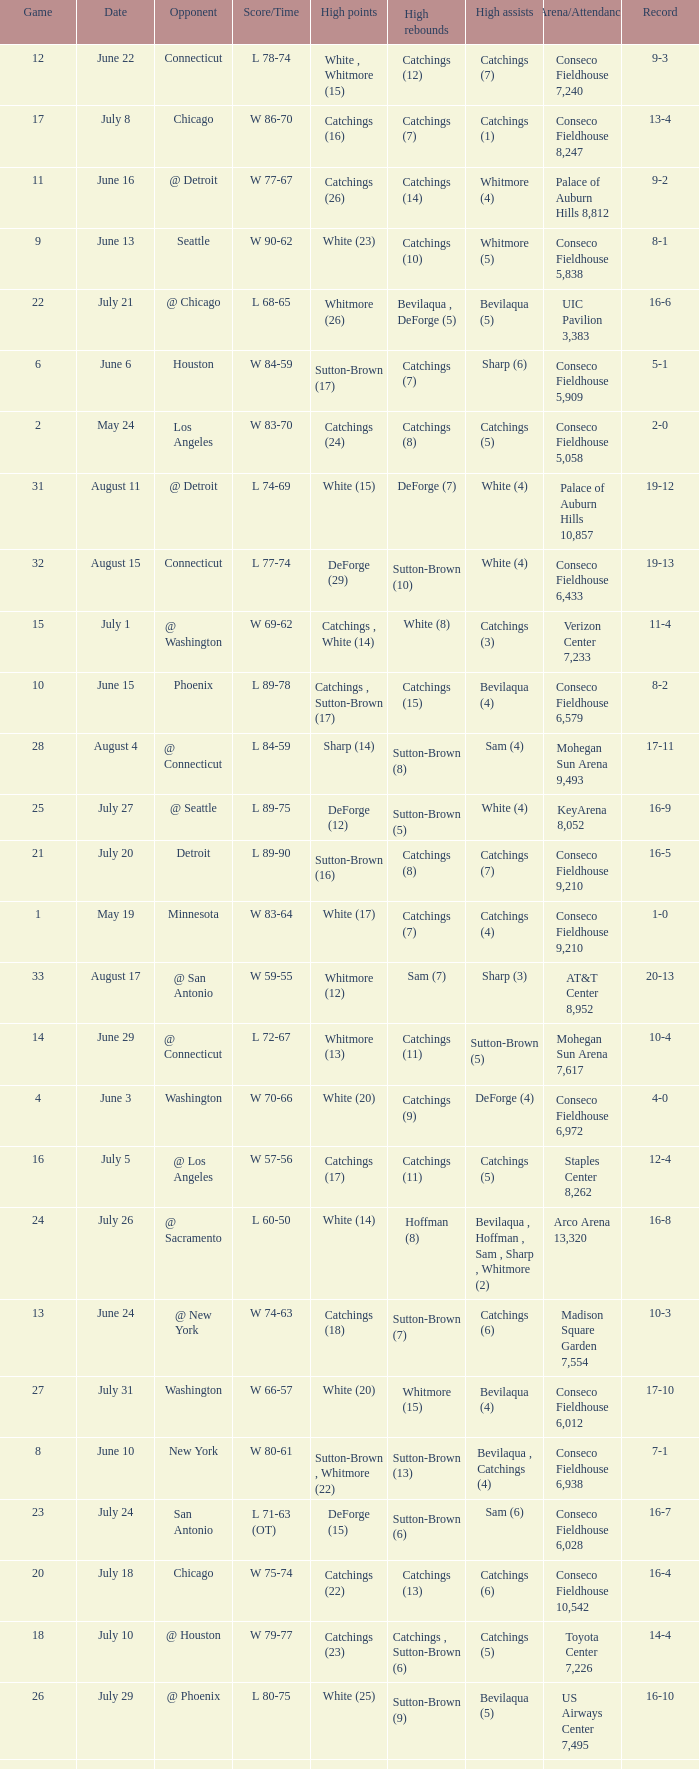Name the date where score time is w 74-63 June 24. 